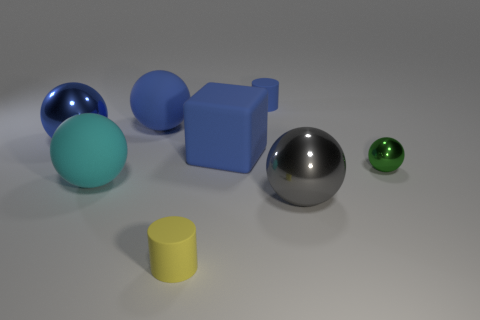Subtract all yellow balls. Subtract all blue cubes. How many balls are left? 5 Add 1 cyan matte spheres. How many objects exist? 9 Subtract all cylinders. How many objects are left? 6 Add 2 green metallic objects. How many green metallic objects exist? 3 Subtract 0 gray blocks. How many objects are left? 8 Subtract all metal things. Subtract all green balls. How many objects are left? 4 Add 7 cyan things. How many cyan things are left? 8 